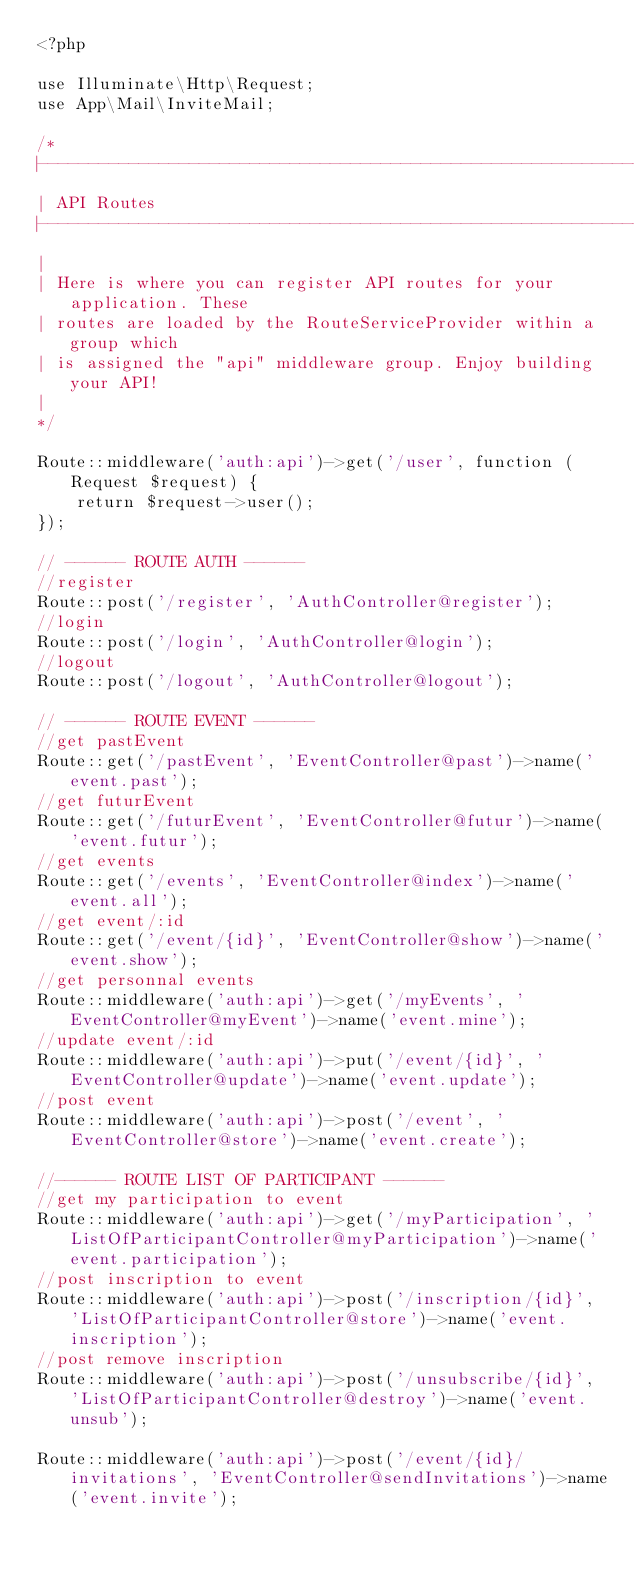<code> <loc_0><loc_0><loc_500><loc_500><_PHP_><?php

use Illuminate\Http\Request;
use App\Mail\InviteMail;

/*
|--------------------------------------------------------------------------
| API Routes
|--------------------------------------------------------------------------
|
| Here is where you can register API routes for your application. These
| routes are loaded by the RouteServiceProvider within a group which
| is assigned the "api" middleware group. Enjoy building your API!
|
*/

Route::middleware('auth:api')->get('/user', function (Request $request) {
    return $request->user();
});

// ------ ROUTE AUTH ------
//register
Route::post('/register', 'AuthController@register');
//login
Route::post('/login', 'AuthController@login');
//logout
Route::post('/logout', 'AuthController@logout');

// ------ ROUTE EVENT ------
//get pastEvent
Route::get('/pastEvent', 'EventController@past')->name('event.past');
//get futurEvent
Route::get('/futurEvent', 'EventController@futur')->name('event.futur');
//get events
Route::get('/events', 'EventController@index')->name('event.all');
//get event/:id
Route::get('/event/{id}', 'EventController@show')->name('event.show');
//get personnal events
Route::middleware('auth:api')->get('/myEvents', 'EventController@myEvent')->name('event.mine');
//update event/:id
Route::middleware('auth:api')->put('/event/{id}', 'EventController@update')->name('event.update');
//post event
Route::middleware('auth:api')->post('/event', 'EventController@store')->name('event.create');

//------ ROUTE LIST OF PARTICIPANT ------
//get my participation to event
Route::middleware('auth:api')->get('/myParticipation', 'ListOfParticipantController@myParticipation')->name('event.participation');
//post inscription to event
Route::middleware('auth:api')->post('/inscription/{id}', 'ListOfParticipantController@store')->name('event.inscription');
//post remove inscription
Route::middleware('auth:api')->post('/unsubscribe/{id}', 'ListOfParticipantController@destroy')->name('event.unsub');

Route::middleware('auth:api')->post('/event/{id}/invitations', 'EventController@sendInvitations')->name('event.invite');
</code> 